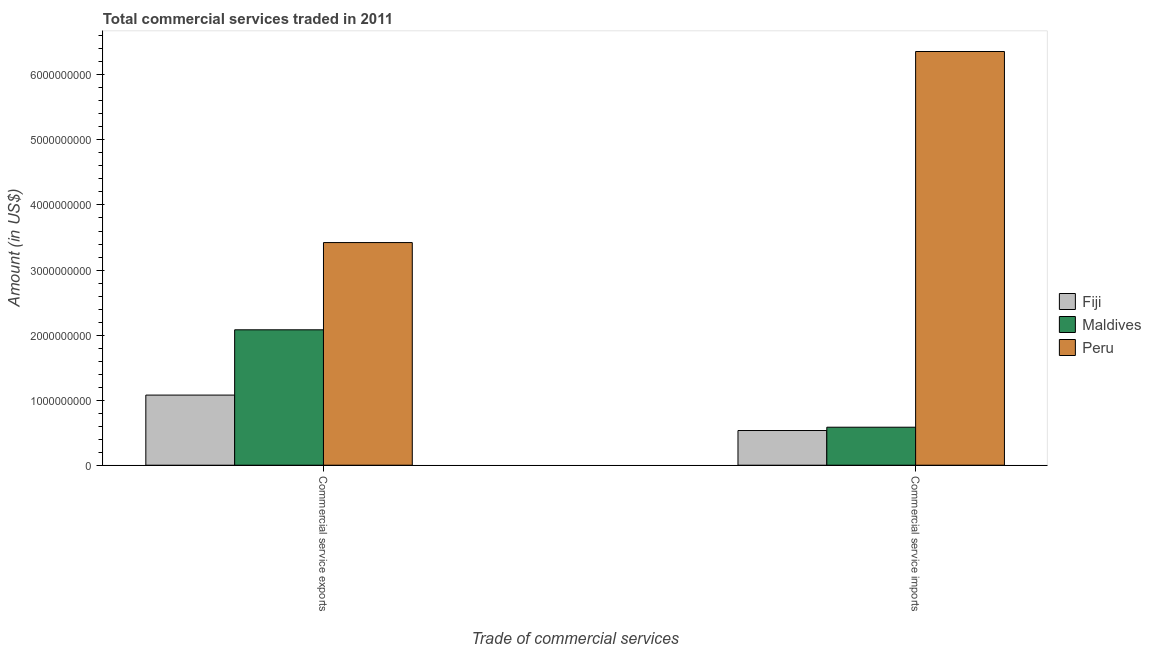Are the number of bars per tick equal to the number of legend labels?
Keep it short and to the point. Yes. Are the number of bars on each tick of the X-axis equal?
Make the answer very short. Yes. How many bars are there on the 1st tick from the left?
Make the answer very short. 3. How many bars are there on the 1st tick from the right?
Your answer should be compact. 3. What is the label of the 2nd group of bars from the left?
Ensure brevity in your answer.  Commercial service imports. What is the amount of commercial service exports in Peru?
Keep it short and to the point. 3.42e+09. Across all countries, what is the maximum amount of commercial service exports?
Provide a succinct answer. 3.42e+09. Across all countries, what is the minimum amount of commercial service imports?
Offer a terse response. 5.33e+08. In which country was the amount of commercial service imports minimum?
Give a very brief answer. Fiji. What is the total amount of commercial service exports in the graph?
Provide a succinct answer. 6.58e+09. What is the difference between the amount of commercial service exports in Maldives and that in Peru?
Your answer should be compact. -1.34e+09. What is the difference between the amount of commercial service imports in Peru and the amount of commercial service exports in Maldives?
Your answer should be very brief. 4.28e+09. What is the average amount of commercial service imports per country?
Offer a terse response. 2.49e+09. What is the difference between the amount of commercial service exports and amount of commercial service imports in Maldives?
Keep it short and to the point. 1.50e+09. What is the ratio of the amount of commercial service exports in Maldives to that in Fiji?
Offer a very short reply. 1.93. What does the 1st bar from the left in Commercial service exports represents?
Your response must be concise. Fiji. What does the 3rd bar from the right in Commercial service exports represents?
Offer a very short reply. Fiji. How many bars are there?
Ensure brevity in your answer.  6. Are all the bars in the graph horizontal?
Ensure brevity in your answer.  No. How many countries are there in the graph?
Provide a succinct answer. 3. What is the difference between two consecutive major ticks on the Y-axis?
Keep it short and to the point. 1.00e+09. Are the values on the major ticks of Y-axis written in scientific E-notation?
Your answer should be very brief. No. Does the graph contain grids?
Provide a succinct answer. No. Where does the legend appear in the graph?
Provide a short and direct response. Center right. How many legend labels are there?
Make the answer very short. 3. What is the title of the graph?
Offer a terse response. Total commercial services traded in 2011. What is the label or title of the X-axis?
Offer a very short reply. Trade of commercial services. What is the label or title of the Y-axis?
Provide a short and direct response. Amount (in US$). What is the Amount (in US$) in Fiji in Commercial service exports?
Your answer should be very brief. 1.08e+09. What is the Amount (in US$) of Maldives in Commercial service exports?
Your answer should be compact. 2.08e+09. What is the Amount (in US$) in Peru in Commercial service exports?
Provide a succinct answer. 3.42e+09. What is the Amount (in US$) of Fiji in Commercial service imports?
Make the answer very short. 5.33e+08. What is the Amount (in US$) in Maldives in Commercial service imports?
Your response must be concise. 5.84e+08. What is the Amount (in US$) in Peru in Commercial service imports?
Ensure brevity in your answer.  6.36e+09. Across all Trade of commercial services, what is the maximum Amount (in US$) in Fiji?
Offer a very short reply. 1.08e+09. Across all Trade of commercial services, what is the maximum Amount (in US$) of Maldives?
Offer a terse response. 2.08e+09. Across all Trade of commercial services, what is the maximum Amount (in US$) of Peru?
Your answer should be compact. 6.36e+09. Across all Trade of commercial services, what is the minimum Amount (in US$) in Fiji?
Offer a terse response. 5.33e+08. Across all Trade of commercial services, what is the minimum Amount (in US$) of Maldives?
Your response must be concise. 5.84e+08. Across all Trade of commercial services, what is the minimum Amount (in US$) of Peru?
Offer a terse response. 3.42e+09. What is the total Amount (in US$) of Fiji in the graph?
Ensure brevity in your answer.  1.61e+09. What is the total Amount (in US$) in Maldives in the graph?
Make the answer very short. 2.67e+09. What is the total Amount (in US$) of Peru in the graph?
Your answer should be compact. 9.78e+09. What is the difference between the Amount (in US$) of Fiji in Commercial service exports and that in Commercial service imports?
Your answer should be very brief. 5.45e+08. What is the difference between the Amount (in US$) in Maldives in Commercial service exports and that in Commercial service imports?
Your answer should be compact. 1.50e+09. What is the difference between the Amount (in US$) of Peru in Commercial service exports and that in Commercial service imports?
Keep it short and to the point. -2.94e+09. What is the difference between the Amount (in US$) in Fiji in Commercial service exports and the Amount (in US$) in Maldives in Commercial service imports?
Your answer should be very brief. 4.94e+08. What is the difference between the Amount (in US$) of Fiji in Commercial service exports and the Amount (in US$) of Peru in Commercial service imports?
Offer a terse response. -5.28e+09. What is the difference between the Amount (in US$) in Maldives in Commercial service exports and the Amount (in US$) in Peru in Commercial service imports?
Give a very brief answer. -4.28e+09. What is the average Amount (in US$) of Fiji per Trade of commercial services?
Give a very brief answer. 8.06e+08. What is the average Amount (in US$) of Maldives per Trade of commercial services?
Provide a short and direct response. 1.33e+09. What is the average Amount (in US$) in Peru per Trade of commercial services?
Your answer should be compact. 4.89e+09. What is the difference between the Amount (in US$) of Fiji and Amount (in US$) of Maldives in Commercial service exports?
Ensure brevity in your answer.  -1.00e+09. What is the difference between the Amount (in US$) in Fiji and Amount (in US$) in Peru in Commercial service exports?
Ensure brevity in your answer.  -2.34e+09. What is the difference between the Amount (in US$) of Maldives and Amount (in US$) of Peru in Commercial service exports?
Your response must be concise. -1.34e+09. What is the difference between the Amount (in US$) of Fiji and Amount (in US$) of Maldives in Commercial service imports?
Your response must be concise. -5.07e+07. What is the difference between the Amount (in US$) in Fiji and Amount (in US$) in Peru in Commercial service imports?
Provide a succinct answer. -5.83e+09. What is the difference between the Amount (in US$) in Maldives and Amount (in US$) in Peru in Commercial service imports?
Provide a succinct answer. -5.78e+09. What is the ratio of the Amount (in US$) in Fiji in Commercial service exports to that in Commercial service imports?
Make the answer very short. 2.02. What is the ratio of the Amount (in US$) of Maldives in Commercial service exports to that in Commercial service imports?
Your answer should be compact. 3.56. What is the ratio of the Amount (in US$) in Peru in Commercial service exports to that in Commercial service imports?
Your answer should be very brief. 0.54. What is the difference between the highest and the second highest Amount (in US$) of Fiji?
Provide a short and direct response. 5.45e+08. What is the difference between the highest and the second highest Amount (in US$) of Maldives?
Make the answer very short. 1.50e+09. What is the difference between the highest and the second highest Amount (in US$) of Peru?
Your answer should be compact. 2.94e+09. What is the difference between the highest and the lowest Amount (in US$) of Fiji?
Make the answer very short. 5.45e+08. What is the difference between the highest and the lowest Amount (in US$) of Maldives?
Offer a terse response. 1.50e+09. What is the difference between the highest and the lowest Amount (in US$) in Peru?
Ensure brevity in your answer.  2.94e+09. 